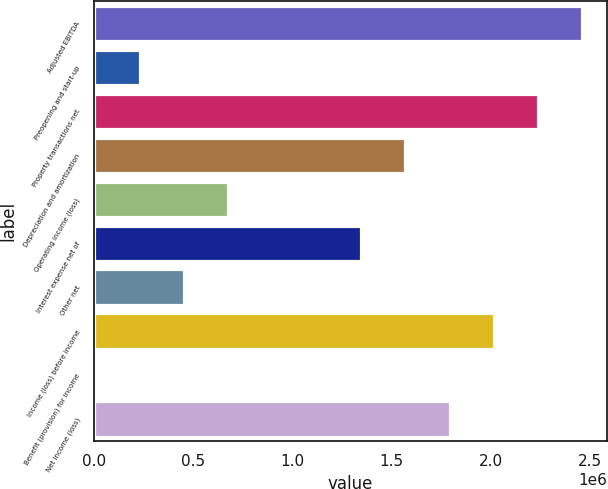<chart> <loc_0><loc_0><loc_500><loc_500><bar_chart><fcel>Adjusted EBITDA<fcel>Preopening and start-up<fcel>Property transactions net<fcel>Depreciation and amortization<fcel>Operating income (loss)<fcel>Interest expense net of<fcel>Other net<fcel>Income (loss) before income<fcel>Benefit (provision) for income<fcel>Net income (loss)<nl><fcel>2.46215e+06<fcel>229827<fcel>2.23892e+06<fcel>1.56922e+06<fcel>676292<fcel>1.34599e+06<fcel>453059<fcel>2.01569e+06<fcel>6594<fcel>1.79245e+06<nl></chart> 